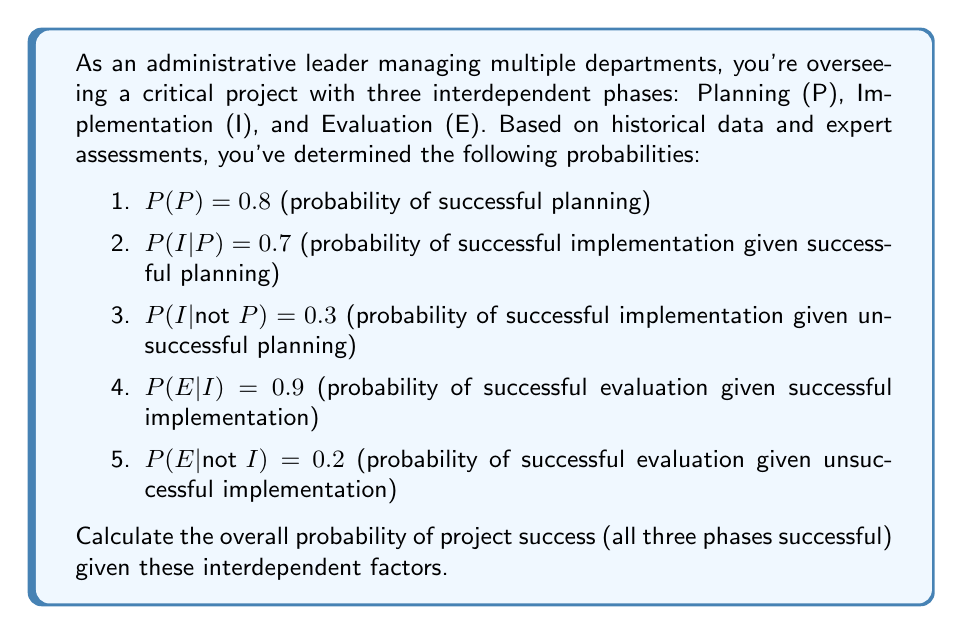Solve this math problem. To solve this problem, we'll use the law of total probability and the multiplication rule for conditional probabilities. Let's break it down step by step:

1. We need to calculate P(P ∩ I ∩ E), which is the probability of all three phases being successful.

2. We can express this as:
   $$P(P ∩ I ∩ E) = P(P) \cdot P(I|P) \cdot P(E|I)$$

3. We're given:
   $$P(P) = 0.8$$
   $$P(I|P) = 0.7$$
   $$P(E|I) = 0.9$$

4. Substituting these values:
   $$P(P ∩ I ∩ E) = 0.8 \cdot 0.7 \cdot 0.9$$

5. Calculating:
   $$P(P ∩ I ∩ E) = 0.504$$

Therefore, the overall probability of project success (all three phases successful) is 0.504 or 50.4%.
Answer: 0.504 or 50.4% 